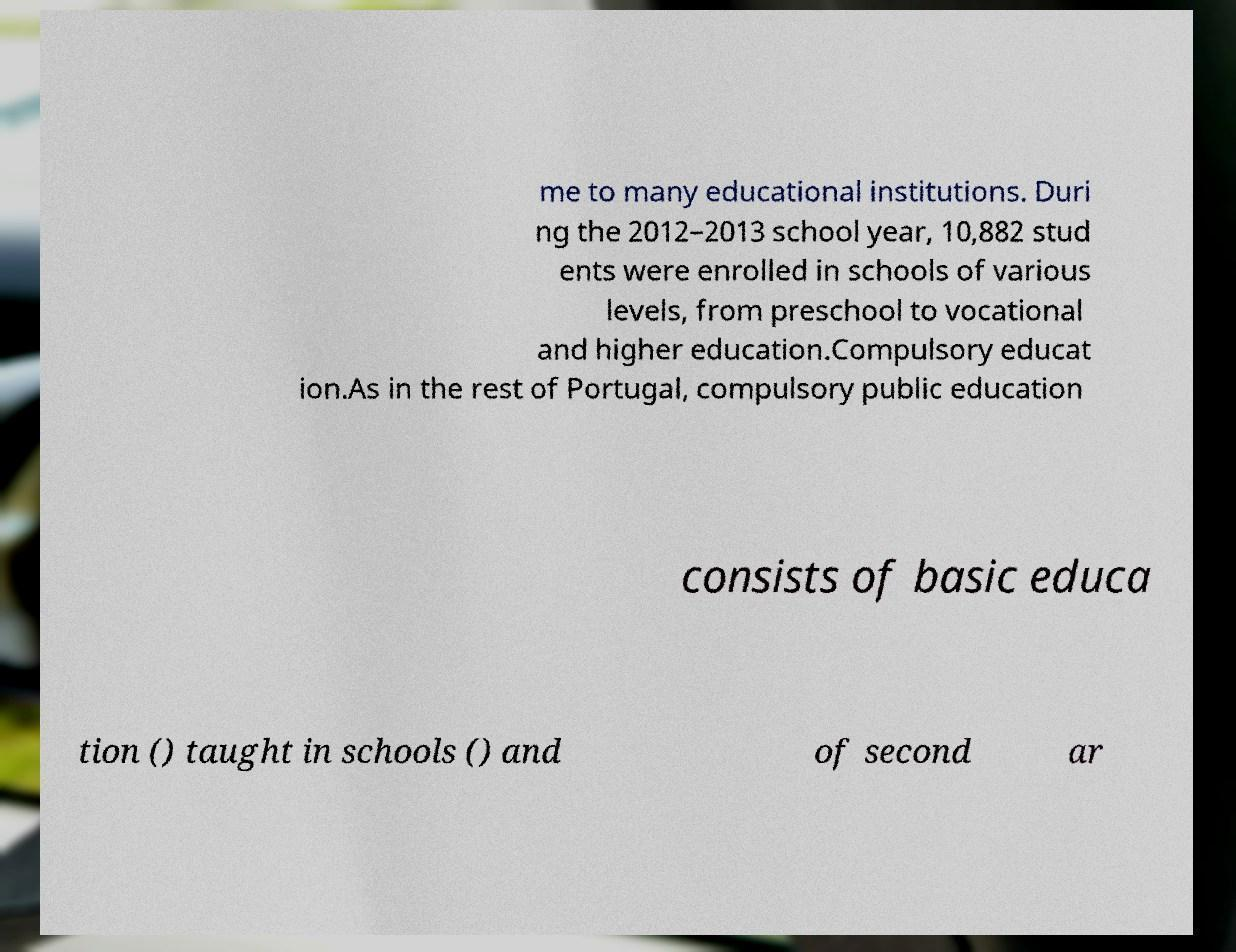What messages or text are displayed in this image? I need them in a readable, typed format. me to many educational institutions. Duri ng the 2012–2013 school year, 10,882 stud ents were enrolled in schools of various levels, from preschool to vocational and higher education.Compulsory educat ion.As in the rest of Portugal, compulsory public education consists of basic educa tion () taught in schools () and of second ar 